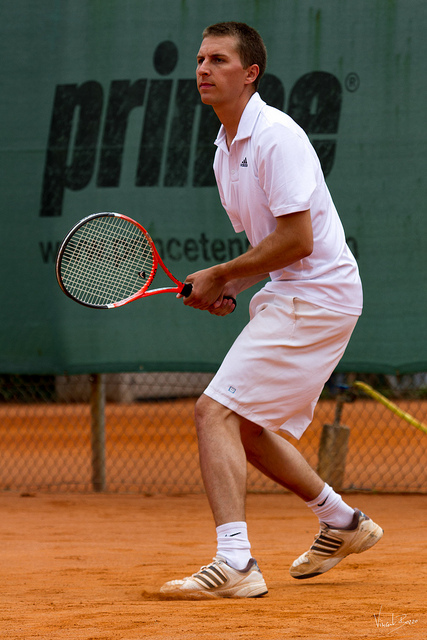Please transcribe the text information in this image. prime 